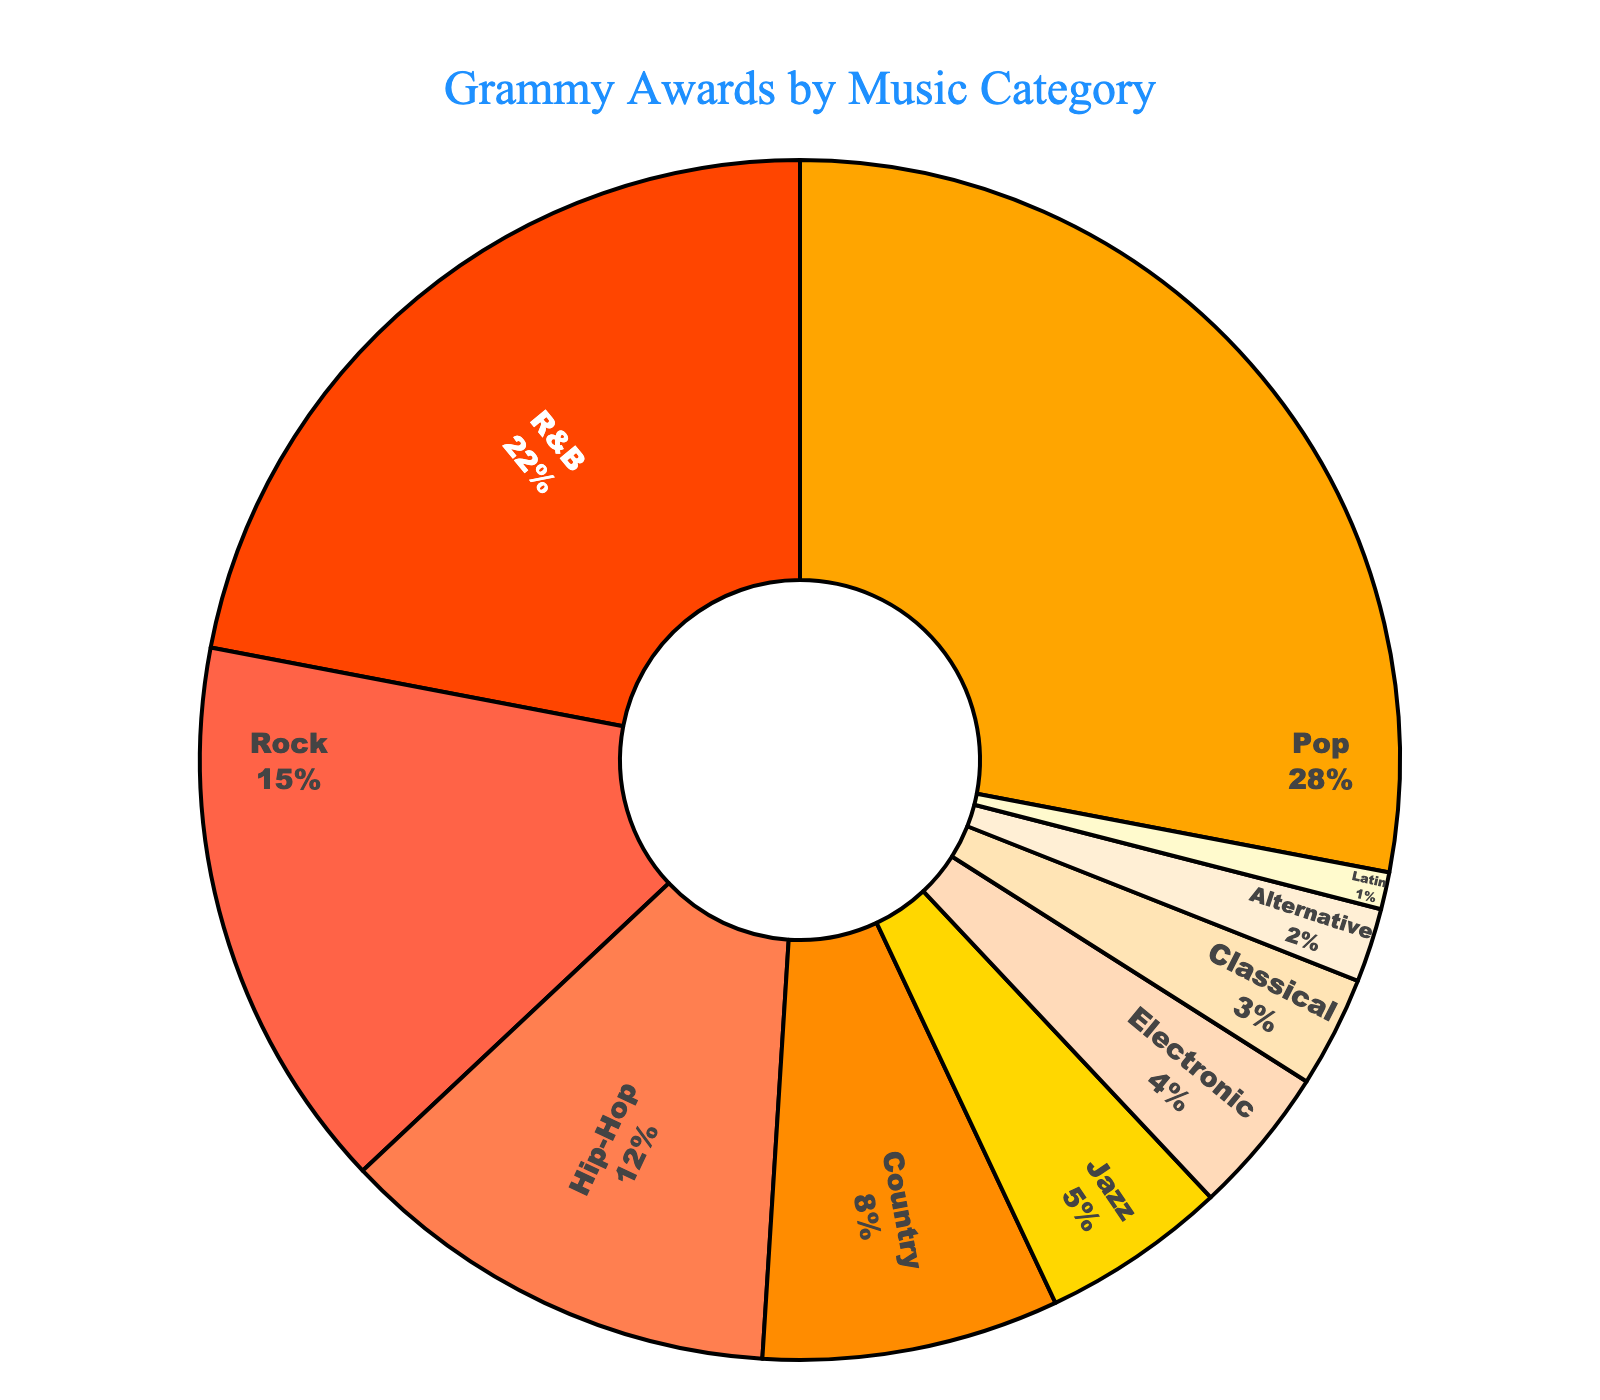What's the category with the highest percentage of Grammy Awards? Look at the pie chart and identify the section with the largest size. The category "Pop" occupies the largest portion.
Answer: Pop What's the combined percentage of Grammy Awards won by Rock and Hip-Hop artists? Find the percentage values for Rock and Hip-Hop on the chart (15% and 12% respectively) and add them up: 15% + 12% = 27%.
Answer: 27% Which category has a lower percentage of Grammy Awards, Jazz or Electronic? Compare the sizes of the pie sections labeled "Jazz" and "Electronic." Jazz has 5%, while Electronic has 4%, making Electronic the smaller percentage.
Answer: Electronic What is the total percentage of Grammy Awards won by Pop, R&B, and Rock artists? Locate the percentages for Pop (28%), R&B (22%), and Rock (15%). Sum them: 28% + 22% + 15% = 65%.
Answer: 65% Which category has the second smallest percentage of Grammy Awards? Observe the size of each section from largest to smallest and determine the second smallest. The smallest is Latin (1%), and the second smallest is Alternative (2%).
Answer: Alternative How many categories have more than 10% of the Grammy Awards? Identify the sections with percentages over 10%: Pop (28%), R&B (22%), Rock (15%), and Hip-Hop (12%). There are 4 such sections.
Answer: 4 What's the percentage difference in Grammy Awards between R&B and Classical music? Calculate the difference by subtracting Classical's percentage (3%) from R&B's percentage (22%): 22% - 3% = 19%.
Answer: 19% If the categories Electronic and Classical are combined, what percentage of Grammy Awards would they have? Add the percentages of Electronic (4%) and Classical (3%): 4% + 3% = 7%.
Answer: 7% 